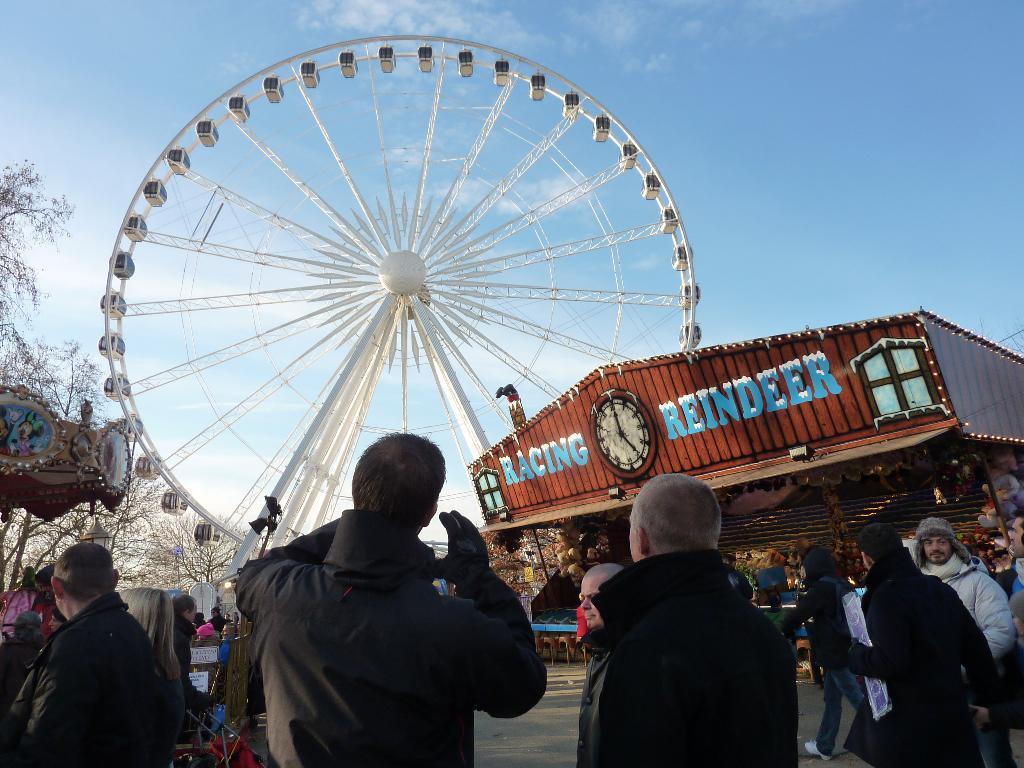Please provide a concise description of this image. In the picture I can see people are standing. I can also see a building, giant wheel, trees and some other objects on the ground. In the background I can see the sky. 